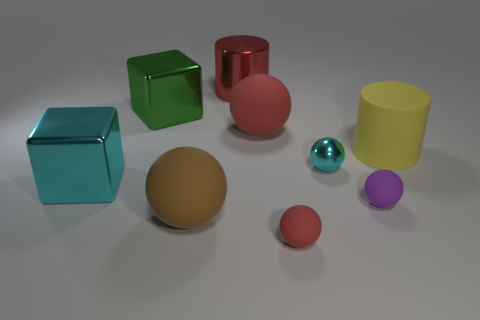Subtract all purple spheres. How many spheres are left? 4 Subtract 1 spheres. How many spheres are left? 4 Subtract all cyan spheres. How many spheres are left? 4 Add 1 purple balls. How many objects exist? 10 Subtract all blocks. How many objects are left? 7 Add 3 small brown metal cylinders. How many small brown metal cylinders exist? 3 Subtract 1 green blocks. How many objects are left? 8 Subtract all blue balls. Subtract all blue cubes. How many balls are left? 5 Subtract all red spheres. How many green cubes are left? 1 Subtract all tiny cyan matte cylinders. Subtract all big yellow rubber cylinders. How many objects are left? 8 